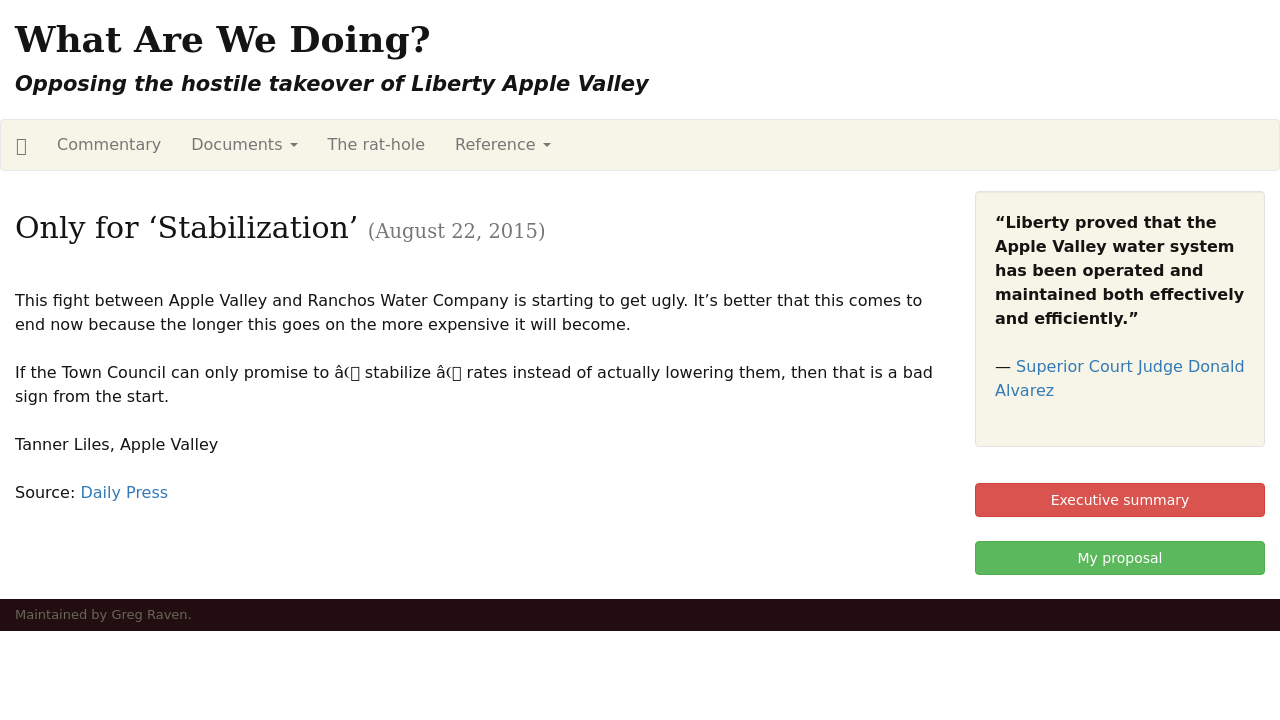How does the visual design of the website support its goal of opposing the takeover? The visual design of the website supports its goal by using a stark, contrasting color scheme that highlights the urgency and seriousness of the issue. The use of large, bold typography in the headlines emphasizes key points and draws attention to the central issues, such as the opposition to the takeover. The straightforward layout and absence of unnecessary graphical elements ensure that the message is delivered clearly and directly, encouraging readers to focus on the factual information and arguments being presented. 